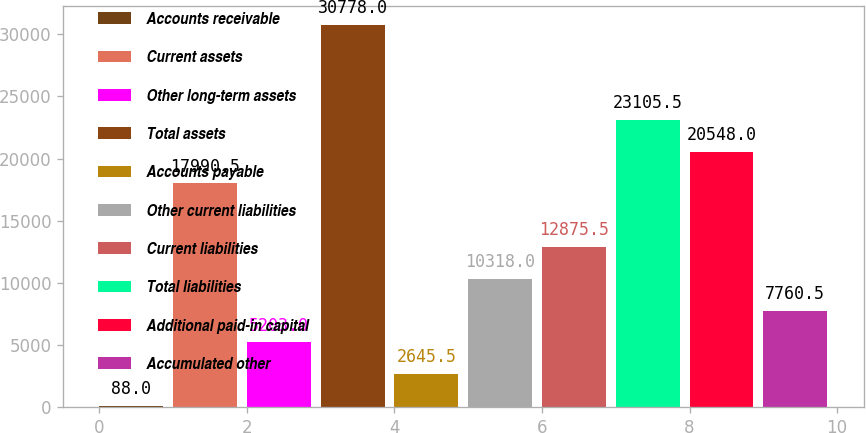<chart> <loc_0><loc_0><loc_500><loc_500><bar_chart><fcel>Accounts receivable<fcel>Current assets<fcel>Other long-term assets<fcel>Total assets<fcel>Accounts payable<fcel>Other current liabilities<fcel>Current liabilities<fcel>Total liabilities<fcel>Additional paid-in capital<fcel>Accumulated other<nl><fcel>88<fcel>17990.5<fcel>5203<fcel>30778<fcel>2645.5<fcel>10318<fcel>12875.5<fcel>23105.5<fcel>20548<fcel>7760.5<nl></chart> 